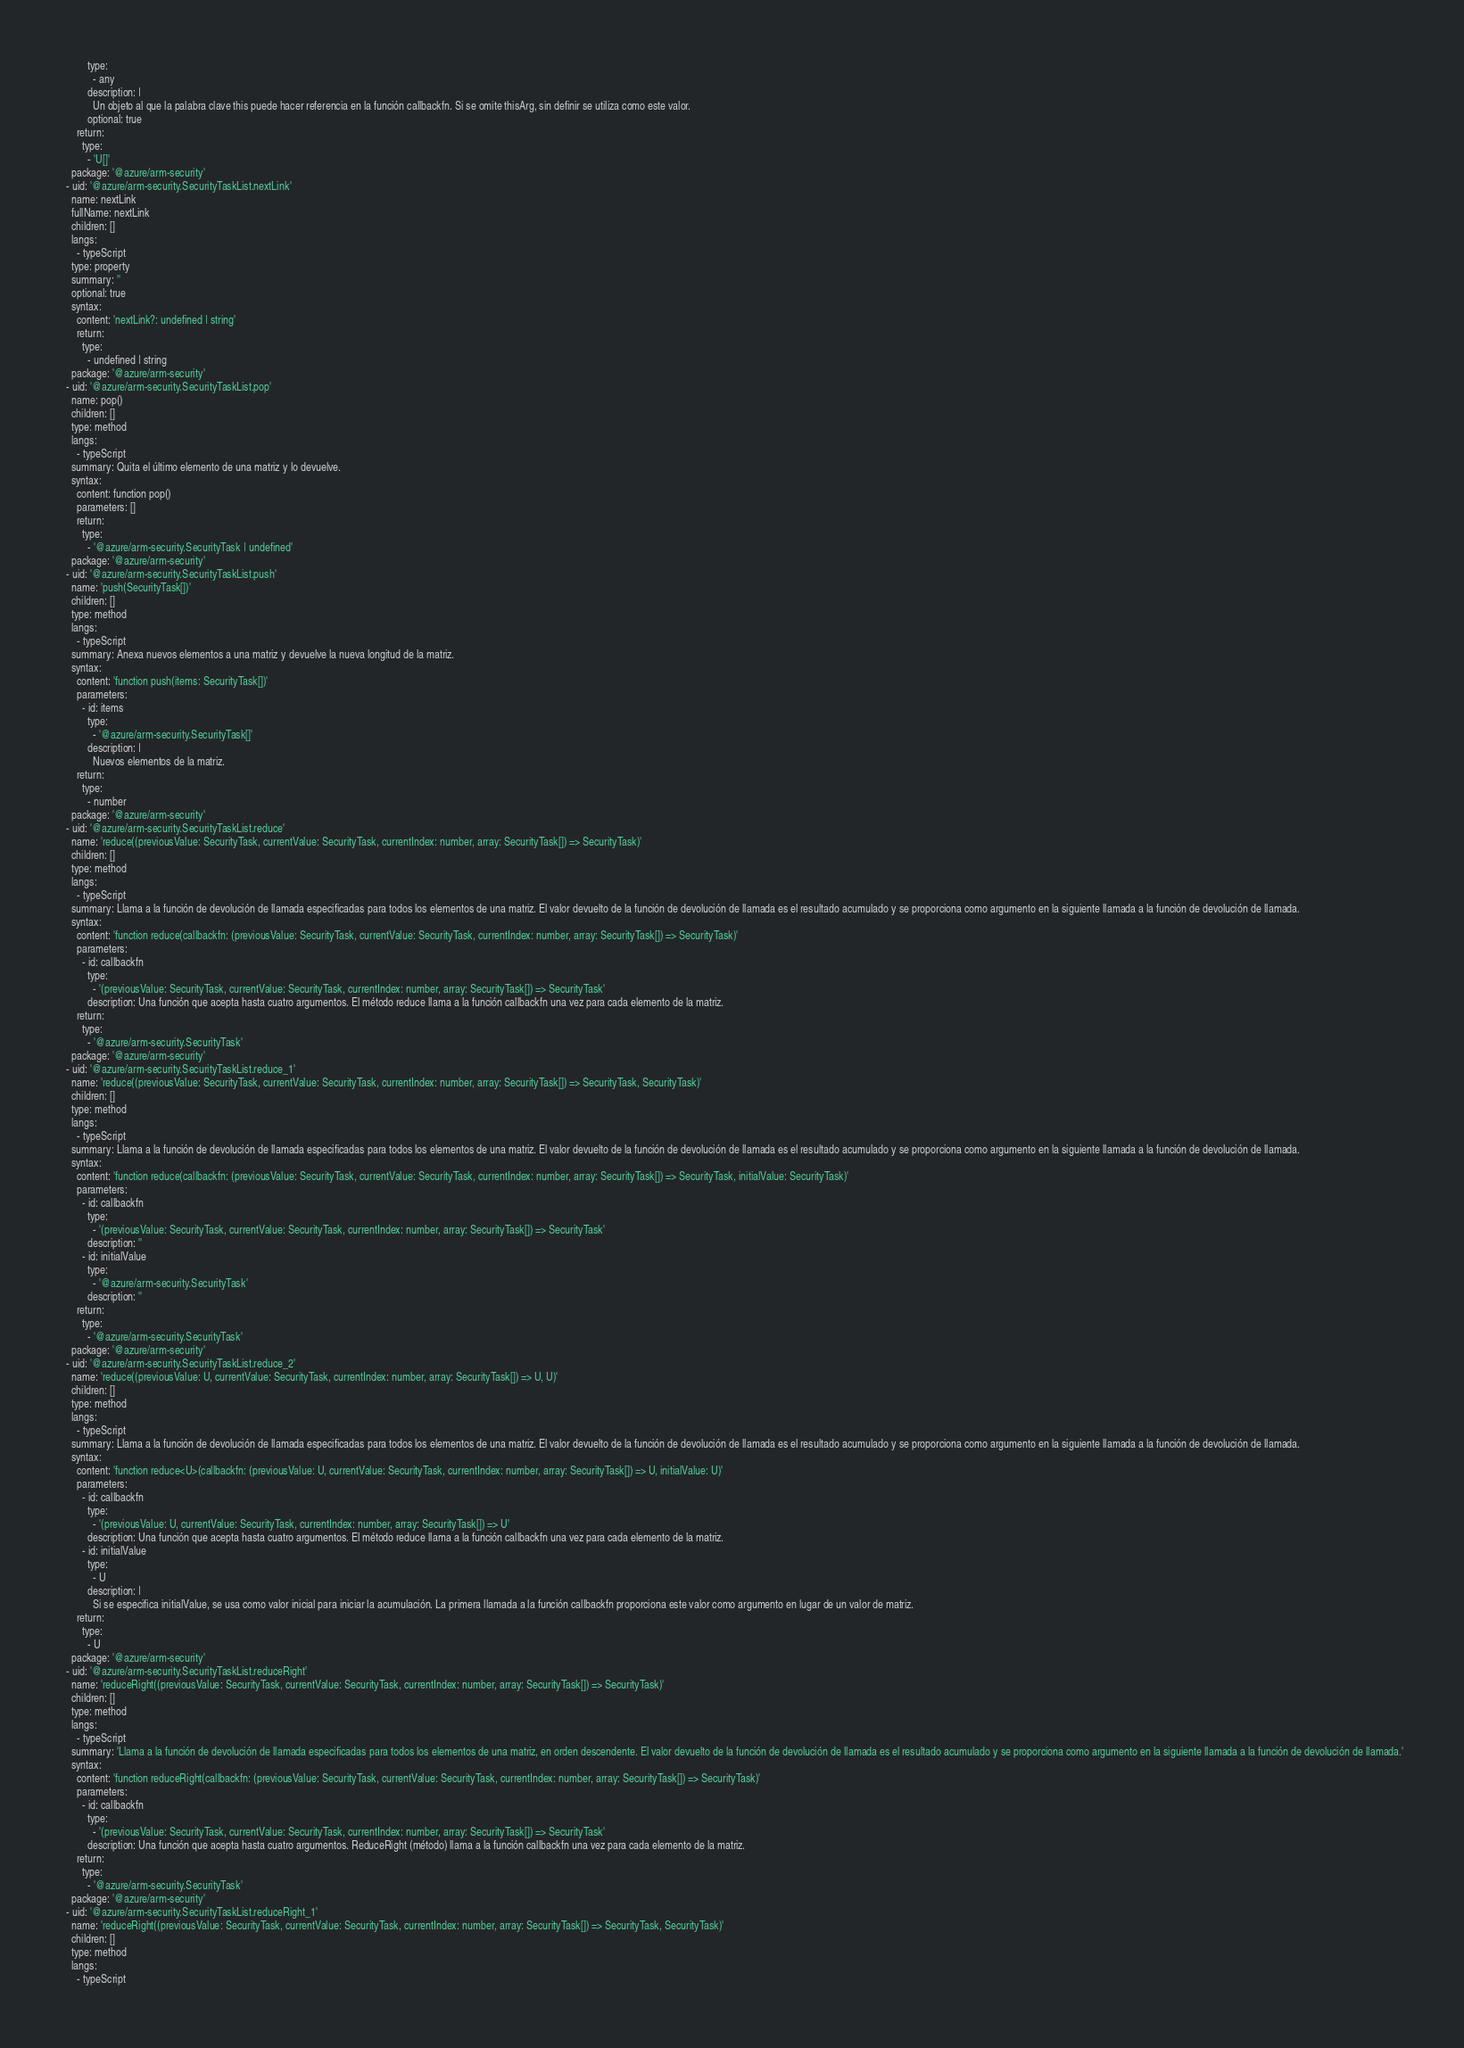<code> <loc_0><loc_0><loc_500><loc_500><_YAML_>          type:
            - any
          description: |
            Un objeto al que la palabra clave this puede hacer referencia en la función callbackfn. Si se omite thisArg, sin definir se utiliza como este valor.
          optional: true
      return:
        type:
          - 'U[]'
    package: '@azure/arm-security'
  - uid: '@azure/arm-security.SecurityTaskList.nextLink'
    name: nextLink
    fullName: nextLink
    children: []
    langs:
      - typeScript
    type: property
    summary: ''
    optional: true
    syntax:
      content: 'nextLink?: undefined | string'
      return:
        type:
          - undefined | string
    package: '@azure/arm-security'
  - uid: '@azure/arm-security.SecurityTaskList.pop'
    name: pop()
    children: []
    type: method
    langs:
      - typeScript
    summary: Quita el último elemento de una matriz y lo devuelve.
    syntax:
      content: function pop()
      parameters: []
      return:
        type:
          - '@azure/arm-security.SecurityTask | undefined'
    package: '@azure/arm-security'
  - uid: '@azure/arm-security.SecurityTaskList.push'
    name: 'push(SecurityTask[])'
    children: []
    type: method
    langs:
      - typeScript
    summary: Anexa nuevos elementos a una matriz y devuelve la nueva longitud de la matriz.
    syntax:
      content: 'function push(items: SecurityTask[])'
      parameters:
        - id: items
          type:
            - '@azure/arm-security.SecurityTask[]'
          description: |
            Nuevos elementos de la matriz.
      return:
        type:
          - number
    package: '@azure/arm-security'
  - uid: '@azure/arm-security.SecurityTaskList.reduce'
    name: 'reduce((previousValue: SecurityTask, currentValue: SecurityTask, currentIndex: number, array: SecurityTask[]) => SecurityTask)'
    children: []
    type: method
    langs:
      - typeScript
    summary: Llama a la función de devolución de llamada especificadas para todos los elementos de una matriz. El valor devuelto de la función de devolución de llamada es el resultado acumulado y se proporciona como argumento en la siguiente llamada a la función de devolución de llamada.
    syntax:
      content: 'function reduce(callbackfn: (previousValue: SecurityTask, currentValue: SecurityTask, currentIndex: number, array: SecurityTask[]) => SecurityTask)'
      parameters:
        - id: callbackfn
          type:
            - '(previousValue: SecurityTask, currentValue: SecurityTask, currentIndex: number, array: SecurityTask[]) => SecurityTask'
          description: Una función que acepta hasta cuatro argumentos. El método reduce llama a la función callbackfn una vez para cada elemento de la matriz.
      return:
        type:
          - '@azure/arm-security.SecurityTask'
    package: '@azure/arm-security'
  - uid: '@azure/arm-security.SecurityTaskList.reduce_1'
    name: 'reduce((previousValue: SecurityTask, currentValue: SecurityTask, currentIndex: number, array: SecurityTask[]) => SecurityTask, SecurityTask)'
    children: []
    type: method
    langs:
      - typeScript
    summary: Llama a la función de devolución de llamada especificadas para todos los elementos de una matriz. El valor devuelto de la función de devolución de llamada es el resultado acumulado y se proporciona como argumento en la siguiente llamada a la función de devolución de llamada.
    syntax:
      content: 'function reduce(callbackfn: (previousValue: SecurityTask, currentValue: SecurityTask, currentIndex: number, array: SecurityTask[]) => SecurityTask, initialValue: SecurityTask)'
      parameters:
        - id: callbackfn
          type:
            - '(previousValue: SecurityTask, currentValue: SecurityTask, currentIndex: number, array: SecurityTask[]) => SecurityTask'
          description: ''
        - id: initialValue
          type:
            - '@azure/arm-security.SecurityTask'
          description: ''
      return:
        type:
          - '@azure/arm-security.SecurityTask'
    package: '@azure/arm-security'
  - uid: '@azure/arm-security.SecurityTaskList.reduce_2'
    name: 'reduce((previousValue: U, currentValue: SecurityTask, currentIndex: number, array: SecurityTask[]) => U, U)'
    children: []
    type: method
    langs:
      - typeScript
    summary: Llama a la función de devolución de llamada especificadas para todos los elementos de una matriz. El valor devuelto de la función de devolución de llamada es el resultado acumulado y se proporciona como argumento en la siguiente llamada a la función de devolución de llamada.
    syntax:
      content: 'function reduce<U>(callbackfn: (previousValue: U, currentValue: SecurityTask, currentIndex: number, array: SecurityTask[]) => U, initialValue: U)'
      parameters:
        - id: callbackfn
          type:
            - '(previousValue: U, currentValue: SecurityTask, currentIndex: number, array: SecurityTask[]) => U'
          description: Una función que acepta hasta cuatro argumentos. El método reduce llama a la función callbackfn una vez para cada elemento de la matriz.
        - id: initialValue
          type:
            - U
          description: |
            Si se especifica initialValue, se usa como valor inicial para iniciar la acumulación. La primera llamada a la función callbackfn proporciona este valor como argumento en lugar de un valor de matriz.
      return:
        type:
          - U
    package: '@azure/arm-security'
  - uid: '@azure/arm-security.SecurityTaskList.reduceRight'
    name: 'reduceRight((previousValue: SecurityTask, currentValue: SecurityTask, currentIndex: number, array: SecurityTask[]) => SecurityTask)'
    children: []
    type: method
    langs:
      - typeScript
    summary: 'Llama a la función de devolución de llamada especificadas para todos los elementos de una matriz, en orden descendente. El valor devuelto de la función de devolución de llamada es el resultado acumulado y se proporciona como argumento en la siguiente llamada a la función de devolución de llamada.'
    syntax:
      content: 'function reduceRight(callbackfn: (previousValue: SecurityTask, currentValue: SecurityTask, currentIndex: number, array: SecurityTask[]) => SecurityTask)'
      parameters:
        - id: callbackfn
          type:
            - '(previousValue: SecurityTask, currentValue: SecurityTask, currentIndex: number, array: SecurityTask[]) => SecurityTask'
          description: Una función que acepta hasta cuatro argumentos. ReduceRight (método) llama a la función callbackfn una vez para cada elemento de la matriz.
      return:
        type:
          - '@azure/arm-security.SecurityTask'
    package: '@azure/arm-security'
  - uid: '@azure/arm-security.SecurityTaskList.reduceRight_1'
    name: 'reduceRight((previousValue: SecurityTask, currentValue: SecurityTask, currentIndex: number, array: SecurityTask[]) => SecurityTask, SecurityTask)'
    children: []
    type: method
    langs:
      - typeScript</code> 